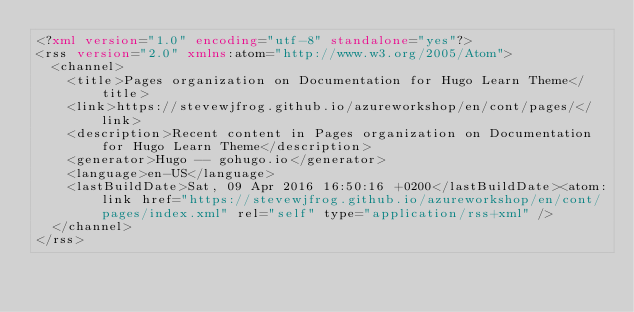Convert code to text. <code><loc_0><loc_0><loc_500><loc_500><_XML_><?xml version="1.0" encoding="utf-8" standalone="yes"?>
<rss version="2.0" xmlns:atom="http://www.w3.org/2005/Atom">
  <channel>
    <title>Pages organization on Documentation for Hugo Learn Theme</title>
    <link>https://stevewjfrog.github.io/azureworkshop/en/cont/pages/</link>
    <description>Recent content in Pages organization on Documentation for Hugo Learn Theme</description>
    <generator>Hugo -- gohugo.io</generator>
    <language>en-US</language>
    <lastBuildDate>Sat, 09 Apr 2016 16:50:16 +0200</lastBuildDate><atom:link href="https://stevewjfrog.github.io/azureworkshop/en/cont/pages/index.xml" rel="self" type="application/rss+xml" />
  </channel>
</rss>
</code> 